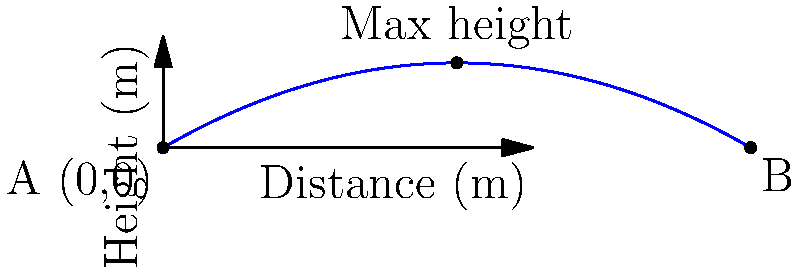A makeshift pipe bomb launcher, common during the Years of Lead, fires a projectile with an initial velocity of 30 m/s at an angle of 30° above the horizontal. Assuming no air resistance, what is the maximum height reached by the projectile, and how far does it travel horizontally before hitting the ground? To solve this problem, we'll use the equations of motion for projectile motion:

1. Determine the vertical and horizontal components of the initial velocity:
   $v_{0x} = v_0 \cos \theta = 30 \cos 30° = 25.98$ m/s
   $v_{0y} = v_0 \sin \theta = 30 \sin 30° = 15$ m/s

2. Calculate the time to reach maximum height:
   At the highest point, $v_y = 0$
   $v_y = v_{0y} - gt$
   $0 = 15 - 9.81t$
   $t_{max} = \frac{15}{9.81} = 1.53$ s

3. Calculate the maximum height:
   $y_{max} = v_{0y}t - \frac{1}{2}gt^2$
   $y_{max} = 15(1.53) - \frac{1}{2}(9.81)(1.53)^2 = 11.48$ m

4. Calculate the total time of flight:
   Total time is twice the time to reach max height
   $t_{total} = 2(1.53) = 3.06$ s

5. Calculate the horizontal distance traveled:
   $x = v_{0x}t$
   $x = 25.98(3.06) = 79.50$ m

Therefore, the maximum height reached is 11.48 m, and the horizontal distance traveled is 79.50 m.
Answer: Maximum height: 11.48 m; Horizontal distance: 79.50 m 